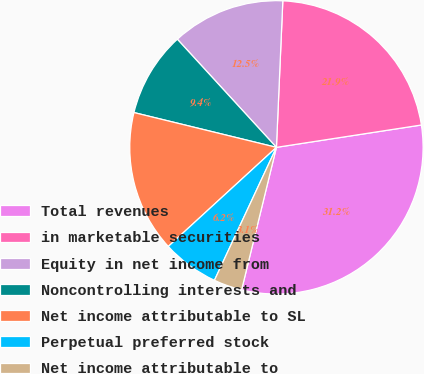Convert chart. <chart><loc_0><loc_0><loc_500><loc_500><pie_chart><fcel>Total revenues<fcel>in marketable securities<fcel>Equity in net income from<fcel>Noncontrolling interests and<fcel>Net income attributable to SL<fcel>Perpetual preferred stock<fcel>Net income attributable to<nl><fcel>31.25%<fcel>21.87%<fcel>12.5%<fcel>9.38%<fcel>15.62%<fcel>6.25%<fcel>3.13%<nl></chart> 